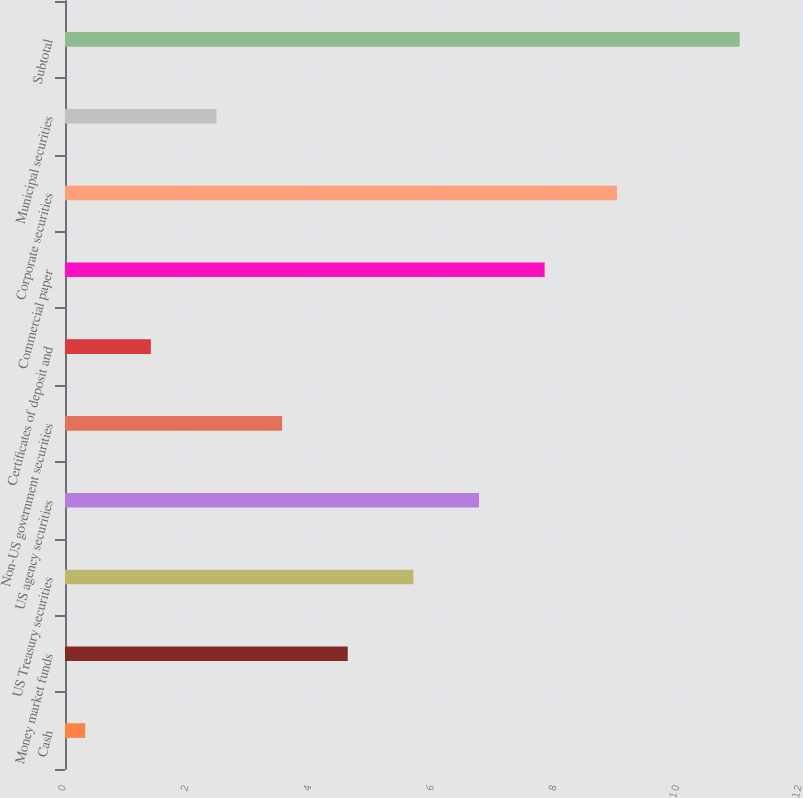<chart> <loc_0><loc_0><loc_500><loc_500><bar_chart><fcel>Cash<fcel>Money market funds<fcel>US Treasury securities<fcel>US agency securities<fcel>Non-US government securities<fcel>Certificates of deposit and<fcel>Commercial paper<fcel>Corporate securities<fcel>Municipal securities<fcel>Subtotal<nl><fcel>0.33<fcel>4.61<fcel>5.68<fcel>6.75<fcel>3.54<fcel>1.4<fcel>7.82<fcel>9<fcel>2.47<fcel>11<nl></chart> 